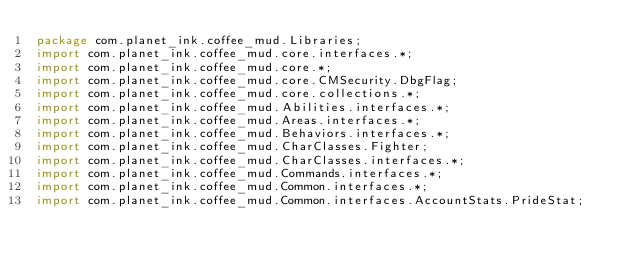Convert code to text. <code><loc_0><loc_0><loc_500><loc_500><_Java_>package com.planet_ink.coffee_mud.Libraries;
import com.planet_ink.coffee_mud.core.interfaces.*;
import com.planet_ink.coffee_mud.core.*;
import com.planet_ink.coffee_mud.core.CMSecurity.DbgFlag;
import com.planet_ink.coffee_mud.core.collections.*;
import com.planet_ink.coffee_mud.Abilities.interfaces.*;
import com.planet_ink.coffee_mud.Areas.interfaces.*;
import com.planet_ink.coffee_mud.Behaviors.interfaces.*;
import com.planet_ink.coffee_mud.CharClasses.Fighter;
import com.planet_ink.coffee_mud.CharClasses.interfaces.*;
import com.planet_ink.coffee_mud.Commands.interfaces.*;
import com.planet_ink.coffee_mud.Common.interfaces.*;
import com.planet_ink.coffee_mud.Common.interfaces.AccountStats.PrideStat;</code> 